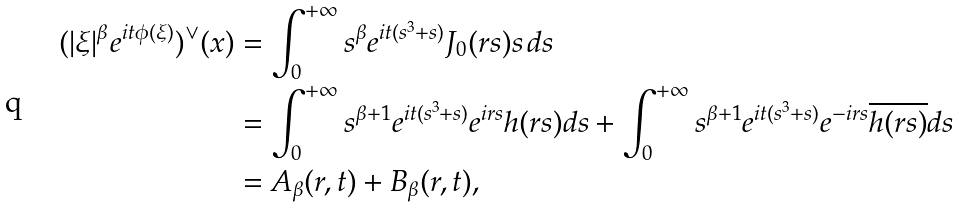Convert formula to latex. <formula><loc_0><loc_0><loc_500><loc_500>( | \xi | ^ { \beta } e ^ { i t \phi ( \xi ) } ) ^ { \vee } ( x ) & = \int _ { 0 } ^ { + \infty } s ^ { \beta } e ^ { i t ( s ^ { 3 } + s ) } J _ { 0 } ( r s ) s \, d s \\ & = \int _ { 0 } ^ { + \infty } s ^ { \beta + 1 } e ^ { i t ( s ^ { 3 } + s ) } e ^ { i r s } h ( r s ) d s + \int _ { 0 } ^ { + \infty } s ^ { \beta + 1 } e ^ { i t ( s ^ { 3 } + s ) } e ^ { - i r s } \overline { h ( r s ) } d s \\ & = A _ { \beta } ( r , t ) + B _ { \beta } ( r , t ) ,</formula> 